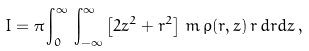Convert formula to latex. <formula><loc_0><loc_0><loc_500><loc_500>I = \pi \int _ { 0 } ^ { \infty } \, \int _ { - \infty } ^ { \infty } \left [ 2 z ^ { 2 } + r ^ { 2 } \right ] \, m \, \rho ( r , z ) \, r \, d r d z \, ,</formula> 